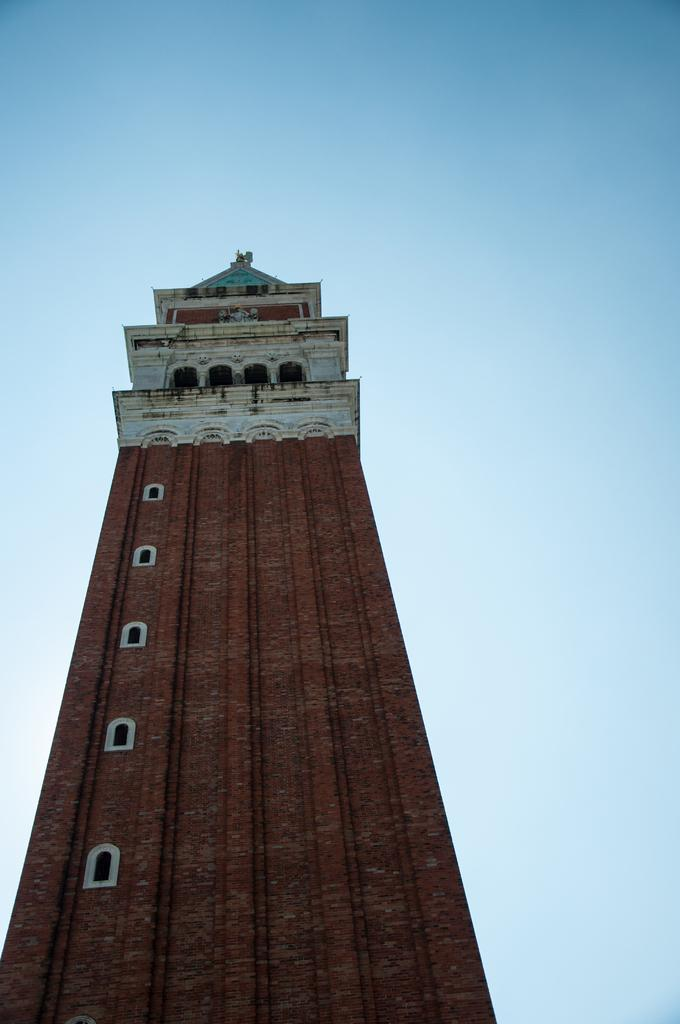What is the main subject in the center of the image? There is a tower in the center of the image. How many apples are on display in the shop in the image? There is no shop or apples present in the image; it features a tower. What type of transport is visible in the image? There is no transport visible in the image; it features a tower. 